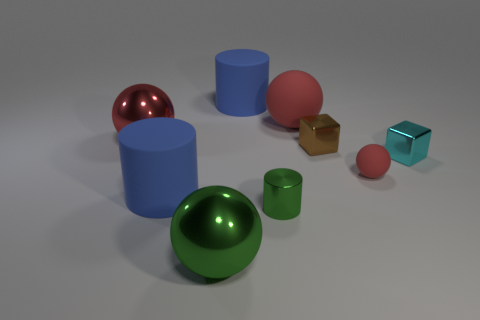There is a brown thing that is the same shape as the cyan shiny object; what is its material?
Offer a terse response. Metal. How many other metallic blocks have the same size as the brown cube?
Offer a terse response. 1. There is a cylinder that is made of the same material as the cyan cube; what size is it?
Ensure brevity in your answer.  Small. What number of cyan metallic objects are the same shape as the brown thing?
Ensure brevity in your answer.  1. What number of brown cubes are there?
Make the answer very short. 1. Do the large red object left of the small metallic cylinder and the large green object have the same shape?
Keep it short and to the point. Yes. There is a brown thing that is the same size as the cyan shiny cube; what material is it?
Ensure brevity in your answer.  Metal. Is there a tiny green cylinder that has the same material as the brown cube?
Provide a short and direct response. Yes. There is a big green thing; is its shape the same as the red matte thing on the left side of the brown shiny cube?
Provide a short and direct response. Yes. What number of blue rubber things are behind the brown cube and in front of the small ball?
Offer a very short reply. 0. 